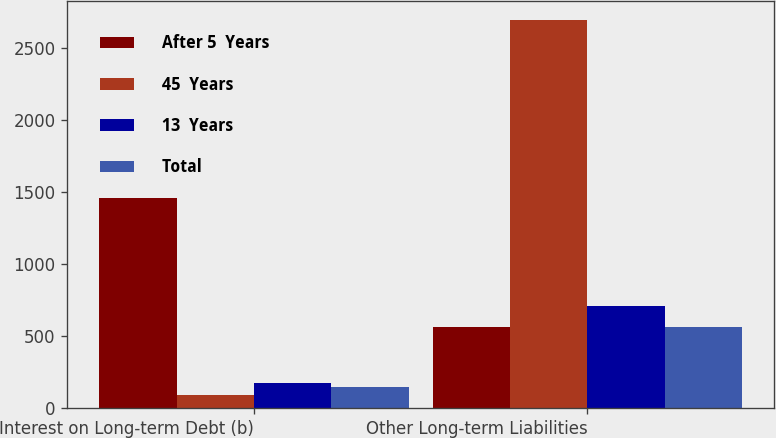Convert chart. <chart><loc_0><loc_0><loc_500><loc_500><stacked_bar_chart><ecel><fcel>Interest on Long-term Debt (b)<fcel>Other Long-term Liabilities<nl><fcel>After 5  Years<fcel>1454<fcel>563<nl><fcel>45  Years<fcel>89<fcel>2688<nl><fcel>13  Years<fcel>173<fcel>710<nl><fcel>Total<fcel>147<fcel>563<nl></chart> 